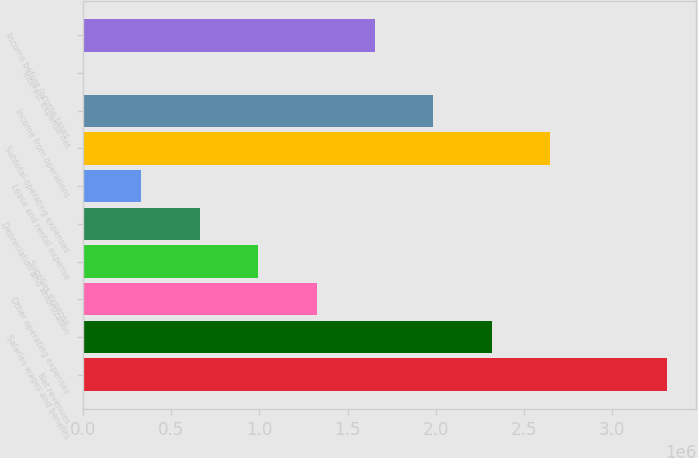Convert chart. <chart><loc_0><loc_0><loc_500><loc_500><bar_chart><fcel>Net revenues<fcel>Salaries wages and benefits<fcel>Other operating expenses<fcel>Supplies expense<fcel>Depreciation and amortization<fcel>Lease and rental expense<fcel>Subtotal-operating expenses<fcel>Income from operations<fcel>Interest expense net<fcel>Income before income taxes<nl><fcel>3.30886e+06<fcel>2.31674e+06<fcel>1.32461e+06<fcel>993903<fcel>663195<fcel>332486<fcel>2.64745e+06<fcel>1.98603e+06<fcel>1778<fcel>1.65532e+06<nl></chart> 